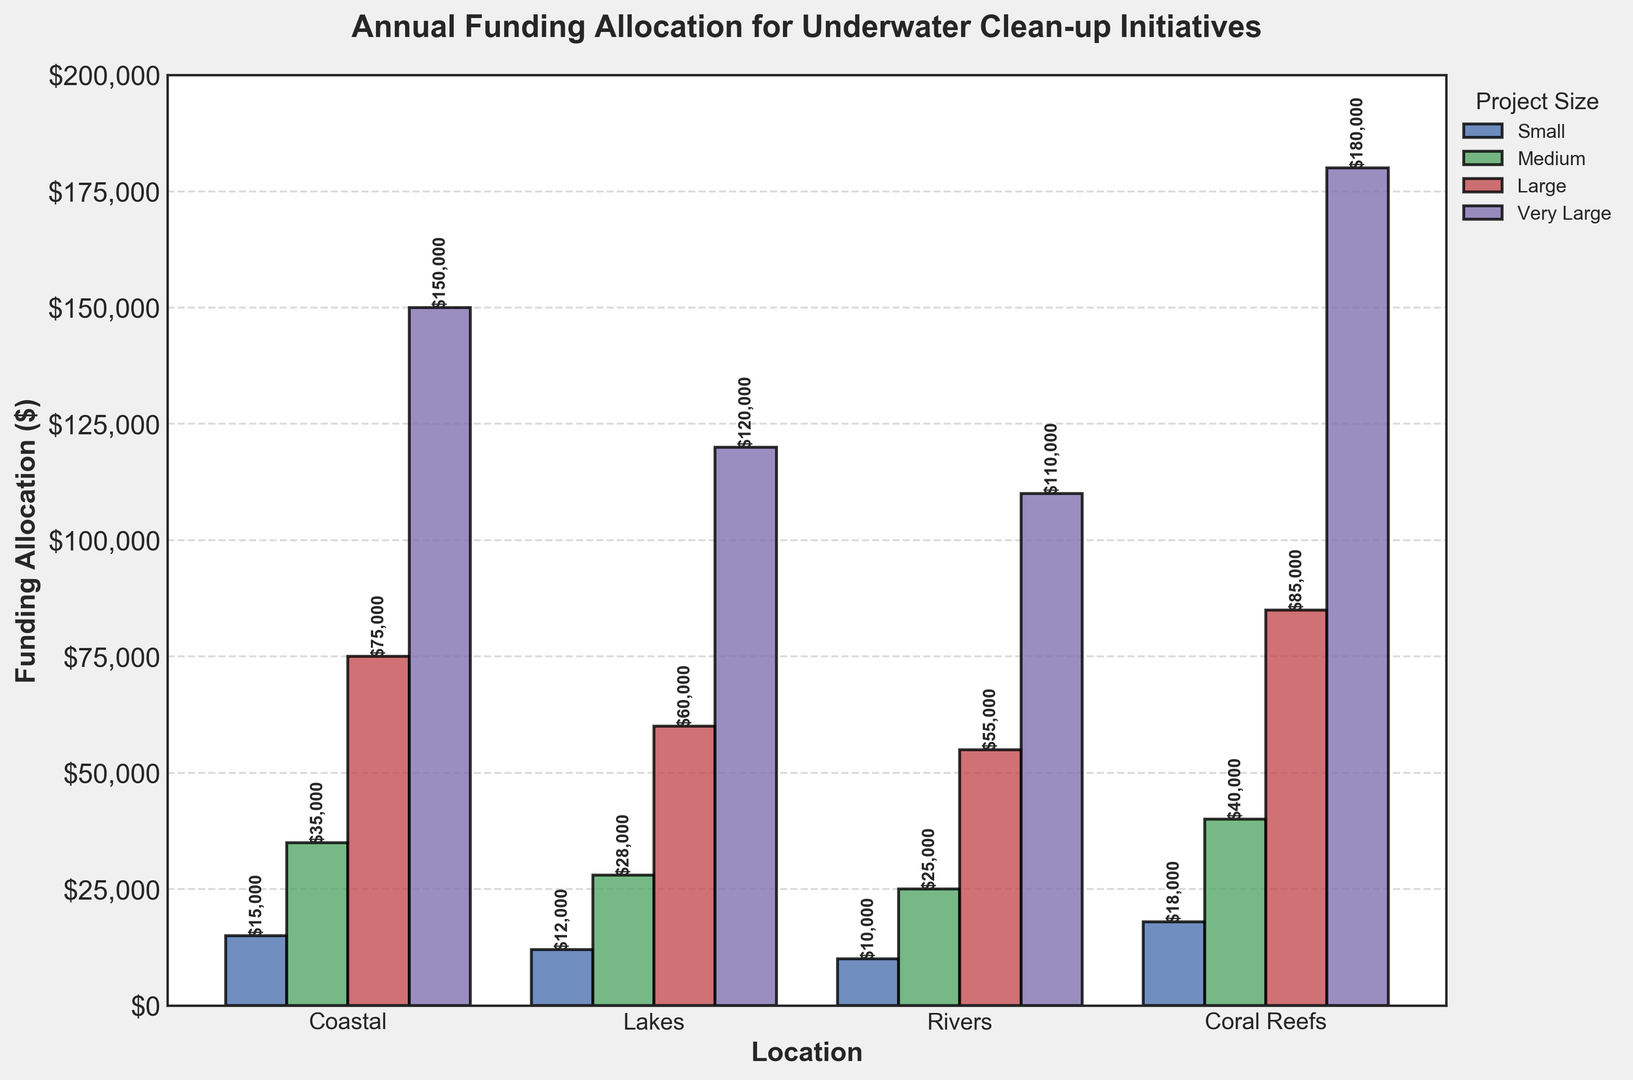what is the total funding allocation for Coral Reefs projects? We need to sum up all the funding allocations for Coral Reefs projects. There are four categories: $18,000 (Small), $40,000 (Medium), $85,000 (Large), and $180,000 (Very Large). Adding these together: 18,000 + 40,000 + 85,000 + 180,000 = 323,000
Answer: 323,000 Which location received the highest total funding allocation across all project sizes? We need to sum up the funding allocations for each location and compare. Coastal: 15,000 + 35,000 + 75,000 + 150,000 = 275,000; Lakes: 12,000 + 28,000 + 60,000 + 120,000 = 220,000; Rivers: 10,000 + 25,000 + 55,000 + 110,000 = 200,000; Coral Reefs: 18,000 + 40,000 + 85,000 + 180,000 = 323,000. Coral Reefs has the highest total funding
Answer: Coral Reefs Which project size received the least funding in Lakes? We compare the funding allocated to projects of different sizes in Lakes. Small: 12,000; Medium: 28,000; Large: 60,000; Very Large: 120,000. The Small projects received the least funding
Answer: Small Is the funding allocation for Medium projects in Rivers greater than for Large projects in Lakes? We compare the funding amounts for Medium projects in Rivers and Large projects in Lakes. Medium in Rivers: 25,000; Large in Lakes: 60,000. 25,000 is not greater than 60,000
Answer: No What is the average funding allocation for Small projects across all locations? We need to sum up the funding allocations for Small projects across all locations and divide by the number of locations. Small projects: Coastal: 15,000; Lakes: 12,000; Rivers: 10,000; Coral Reefs: 18,000. Total: 15,000 + 12,000 + 10,000 + 18,000 = 55,000. Average: 55,000 / 4 = 13,750
Answer: 13,750 What is the difference in funding allocation between Very Large projects in Coastal and Lakes locations? We subtract the funding allocation for Very Large projects in Lakes from the same in Coastal. Coastal: 150,000; Lakes: 120,000. 150,000 - 120,000 = 30,000
Answer: 30,000 Which project size received the highest average funding across all locations? We calculate the average funding for each project size, sum the allocations for each size, and then divide by 4 (the number of locations). Small: (15,000 + 12,000 + 10,000 + 18,000) / 4 = 13,750; Medium: (35,000 + 28,000 + 25,000 + 40,000) / 4 = 32,000; Large: (75,000 + 60,000 + 55,000 + 85,000) / 4 = 68,750; Very Large: (150,000 + 120,000 + 110,000 + 180,000) / 4 = 140,000. The Very Large projects have the highest average funding
Answer: Very Large How much more funding did Very Large Coral Reefs projects receive compared to Small Coastal projects? We subtract the funding allocation for Small Coastal projects from Very Large Coral Reefs projects. Very Large Coral Reefs: 180,000; Small Coastal: 15,000. 180,000 - 15,000 = 165,000
Answer: 165,000 Which location had the least variance in funding allocation across project sizes? We need to calculate the variance in funding allocation for each location and compare. Coastal: Variance of (15,000, 35,000, 75,000, 150,000); Lakes: Variance of (12,000, 28,000, 60,000, 120,000); Rivers: Variance of (10,000, 25,000, 55,000, 110,000); Coral Reefs: Variance of (18,000, 40,000, 85,000, 180,000). Given the values, Lakes have the smallest spacing between the amounts at each increment
Answer: Lakes 